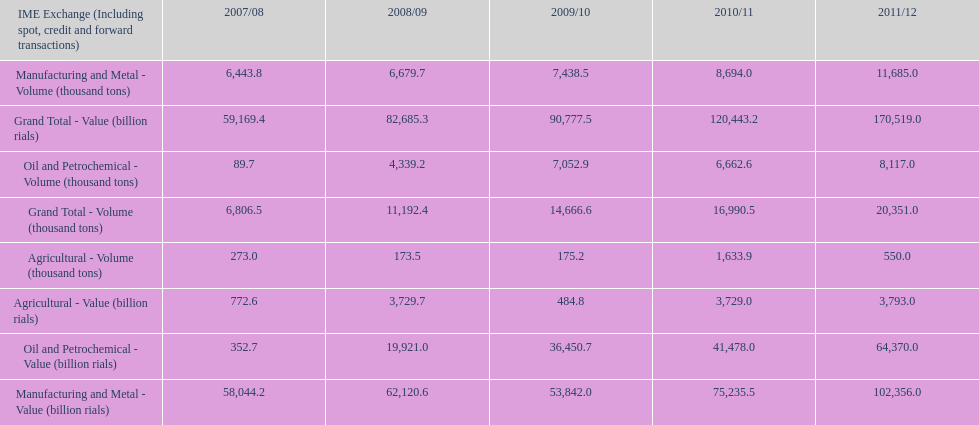How many consecutive year did the grand total value grow in iran? 4. Could you help me parse every detail presented in this table? {'header': ['IME Exchange (Including spot, credit and forward transactions)', '2007/08', '2008/09', '2009/10', '2010/11', '2011/12'], 'rows': [['Manufacturing and Metal - Volume (thousand tons)', '6,443.8', '6,679.7', '7,438.5', '8,694.0', '11,685.0'], ['Grand Total - Value (billion rials)', '59,169.4', '82,685.3', '90,777.5', '120,443.2', '170,519.0'], ['Oil and Petrochemical - Volume (thousand tons)', '89.7', '4,339.2', '7,052.9', '6,662.6', '8,117.0'], ['Grand Total - Volume (thousand tons)', '6,806.5', '11,192.4', '14,666.6', '16,990.5', '20,351.0'], ['Agricultural - Volume (thousand tons)', '273.0', '173.5', '175.2', '1,633.9', '550.0'], ['Agricultural - Value (billion rials)', '772.6', '3,729.7', '484.8', '3,729.0', '3,793.0'], ['Oil and Petrochemical - Value (billion rials)', '352.7', '19,921.0', '36,450.7', '41,478.0', '64,370.0'], ['Manufacturing and Metal - Value (billion rials)', '58,044.2', '62,120.6', '53,842.0', '75,235.5', '102,356.0']]} 